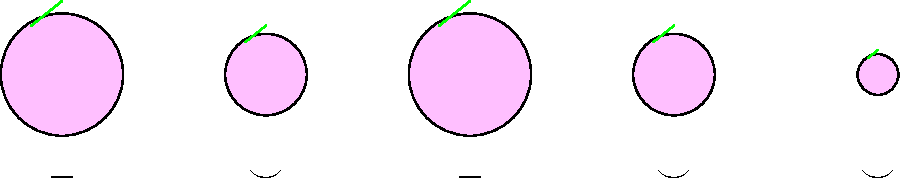Analyze the graphic representation of poetic meter using cherry blossoms. What metrical foot is depicted, and how does it relate to the etymological roots of its name? To answer this question, let's break it down step-by-step:

1. Observe the pattern of cherry blossoms:
   - Large, small, large, small, smaller

2. Notice the symbols beneath each blossom:
   - $-$, $\smile$, $-$, $\smile$, $\smile$

3. Interpret the symbols:
   - $-$ represents a stressed syllable (larger blossom)
   - $\smile$ represents an unstressed syllable (smaller blossom)

4. Identify the pattern:
   - Stressed, unstressed, stressed, unstressed, unstressed
   - This pattern forms two feet: (- ⌣) (- ⌣ ⌣)

5. Recognize the metrical foot:
   - The pattern (- ⌣ ⌣) is known as a dactyl
   - The full line is a dactylic dimeter cataletic (two dactyls with the last syllable cut off)

6. Etymological connection:
   - "Dactyl" comes from the Greek word "daktylos" (δάκτυλος), meaning "finger"
   - The stressed syllable followed by two unstressed syllables mimics the structure of a finger: one long joint followed by two shorter ones

7. Poetic significance:
   - Dactylic meter is often used in epic poetry, creating a rolling, galloping rhythm
   - The use of cherry blossoms adds a whimsical, seasonal touch to the representation
Answer: Dactylic meter; from Greek "daktylos" (finger), mimicking finger structure 